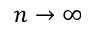Convert formula to latex. <formula><loc_0><loc_0><loc_500><loc_500>n \rightarrow \infty</formula> 